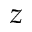Convert formula to latex. <formula><loc_0><loc_0><loc_500><loc_500>z</formula> 